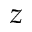Convert formula to latex. <formula><loc_0><loc_0><loc_500><loc_500>z</formula> 